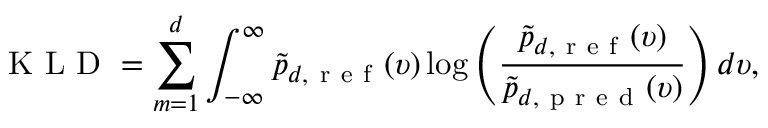Convert formula to latex. <formula><loc_0><loc_0><loc_500><loc_500>K L D = \sum _ { m = 1 } ^ { d } \int _ { - \infty } ^ { \infty } \tilde { p } _ { d , r e f } ( \upsilon ) \log \left ( \frac { \tilde { p } _ { d , r e f } ( \upsilon ) } { \tilde { p } _ { d , p r e d } ( \upsilon ) } \right ) d \upsilon ,</formula> 